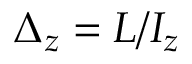<formula> <loc_0><loc_0><loc_500><loc_500>\Delta _ { z } = { L } / I _ { z }</formula> 